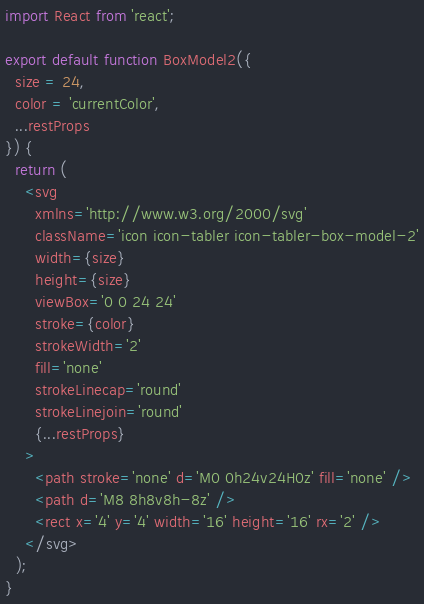Convert code to text. <code><loc_0><loc_0><loc_500><loc_500><_JavaScript_>import React from 'react';

export default function BoxModel2({
  size = 24,
  color = 'currentColor',
  ...restProps
}) {
  return (
    <svg
      xmlns='http://www.w3.org/2000/svg'
      className='icon icon-tabler icon-tabler-box-model-2'
      width={size}
      height={size}
      viewBox='0 0 24 24'
      stroke={color}
      strokeWidth='2'
      fill='none'
      strokeLinecap='round'
      strokeLinejoin='round'
      {...restProps}
    >
      <path stroke='none' d='M0 0h24v24H0z' fill='none' />
      <path d='M8 8h8v8h-8z' />
      <rect x='4' y='4' width='16' height='16' rx='2' />
    </svg>
  );
}
</code> 